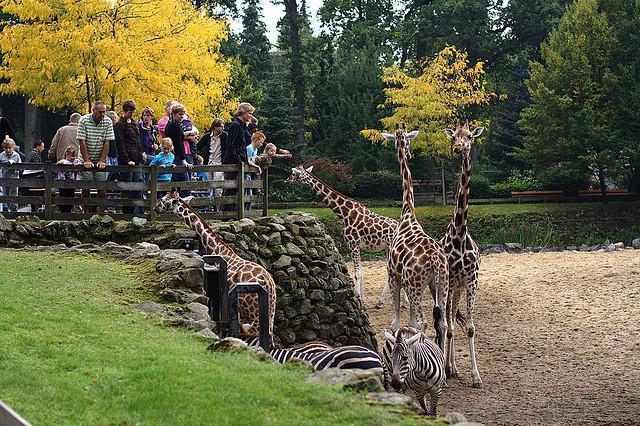What is closest to the giraffe?
Select the accurate answer and provide explanation: 'Answer: answer
Rationale: rationale.'
Options: Baby eel, hat, zebra, baby. Answer: zebra.
Rationale: The question is unspecific, but answer a is a object that is visibly close to the giraffes in question. How many giraffes are standing in the zoo enclosure around the people?
Choose the correct response, then elucidate: 'Answer: answer
Rationale: rationale.'
Options: Four, six, five, three. Answer: four.
Rationale: There are four animals with tall necks. 